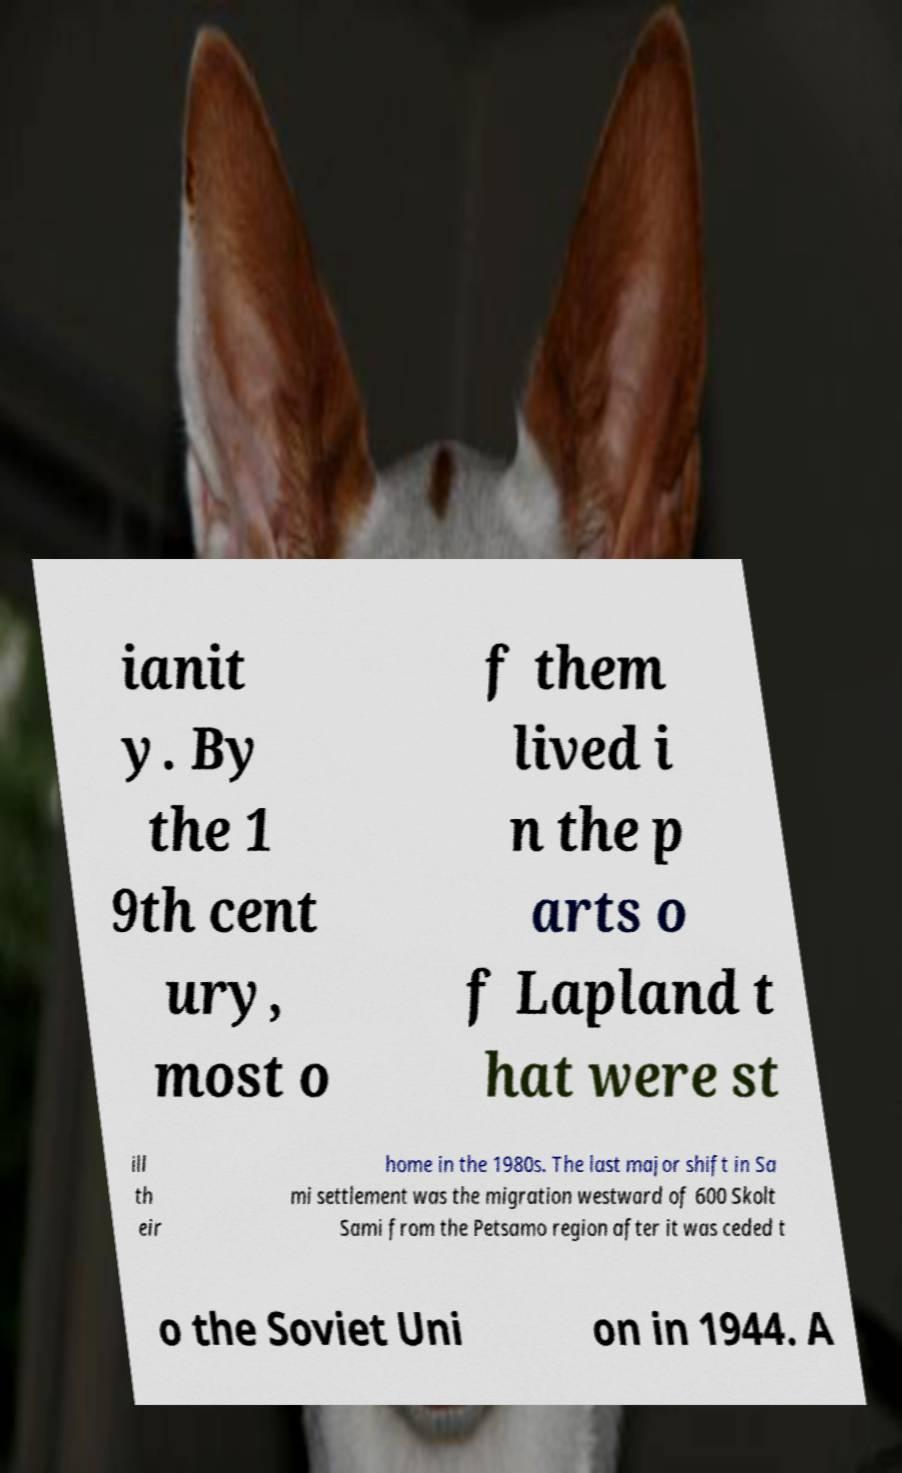What messages or text are displayed in this image? I need them in a readable, typed format. ianit y. By the 1 9th cent ury, most o f them lived i n the p arts o f Lapland t hat were st ill th eir home in the 1980s. The last major shift in Sa mi settlement was the migration westward of 600 Skolt Sami from the Petsamo region after it was ceded t o the Soviet Uni on in 1944. A 